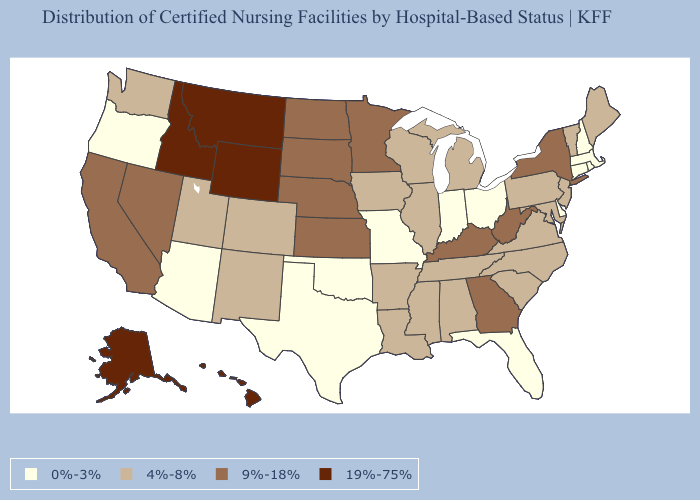Does Pennsylvania have the highest value in the Northeast?
Quick response, please. No. What is the value of Montana?
Be succinct. 19%-75%. What is the highest value in the USA?
Answer briefly. 19%-75%. Does the map have missing data?
Be succinct. No. What is the lowest value in states that border Iowa?
Give a very brief answer. 0%-3%. Name the states that have a value in the range 4%-8%?
Concise answer only. Alabama, Arkansas, Colorado, Illinois, Iowa, Louisiana, Maine, Maryland, Michigan, Mississippi, New Jersey, New Mexico, North Carolina, Pennsylvania, South Carolina, Tennessee, Utah, Vermont, Virginia, Washington, Wisconsin. What is the value of Idaho?
Answer briefly. 19%-75%. What is the value of Delaware?
Give a very brief answer. 0%-3%. Does Kansas have the lowest value in the USA?
Keep it brief. No. What is the value of Utah?
Quick response, please. 4%-8%. What is the lowest value in states that border Missouri?
Concise answer only. 0%-3%. What is the value of New Mexico?
Be succinct. 4%-8%. Does Kentucky have the highest value in the USA?
Keep it brief. No. Among the states that border Wyoming , does Nebraska have the highest value?
Concise answer only. No. Name the states that have a value in the range 0%-3%?
Be succinct. Arizona, Connecticut, Delaware, Florida, Indiana, Massachusetts, Missouri, New Hampshire, Ohio, Oklahoma, Oregon, Rhode Island, Texas. 